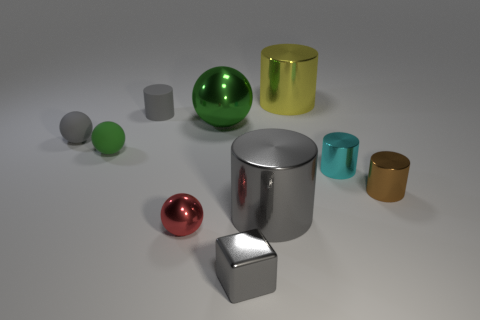There is a metallic cylinder behind the gray cylinder that is behind the brown metallic cylinder that is in front of the cyan cylinder; how big is it?
Give a very brief answer. Large. What number of other objects are there of the same material as the block?
Give a very brief answer. 6. The shiny sphere that is in front of the tiny green matte thing is what color?
Ensure brevity in your answer.  Red. What material is the gray cylinder on the left side of the big metal thing that is on the left side of the tiny gray thing to the right of the red thing?
Provide a short and direct response. Rubber. Is there a blue rubber object of the same shape as the brown metal thing?
Your answer should be very brief. No. What shape is the green thing that is the same size as the yellow cylinder?
Give a very brief answer. Sphere. How many metal things are both on the right side of the yellow metallic cylinder and left of the tiny gray cube?
Keep it short and to the point. 0. Are there fewer metal cubes behind the small green object than small cyan shiny things?
Offer a very short reply. Yes. Is there a matte object of the same size as the gray matte ball?
Provide a succinct answer. Yes. The big ball that is made of the same material as the red thing is what color?
Ensure brevity in your answer.  Green. 